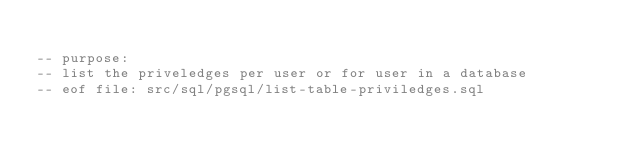Convert code to text. <code><loc_0><loc_0><loc_500><loc_500><_SQL_>
-- purpose: 
-- list the priveledges per user or for user in a database
-- eof file: src/sql/pgsql/list-table-priviledges.sql
</code> 